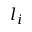<formula> <loc_0><loc_0><loc_500><loc_500>l _ { i }</formula> 